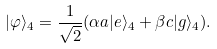Convert formula to latex. <formula><loc_0><loc_0><loc_500><loc_500>| \varphi \rangle _ { 4 } = \frac { 1 } { \sqrt { 2 } } ( \alpha a | e \rangle _ { 4 } + \beta c | g \rangle _ { 4 } ) .</formula> 